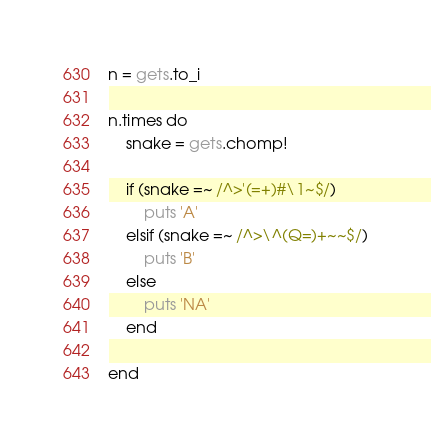<code> <loc_0><loc_0><loc_500><loc_500><_Ruby_>n = gets.to_i

n.times do
	snake = gets.chomp!
    
    if (snake =~ /^>'(=+)#\1~$/)
    	puts 'A'
    elsif (snake =~ /^>\^(Q=)+~~$/)
    	puts 'B'
    else
    	puts 'NA'
    end
    
end</code> 